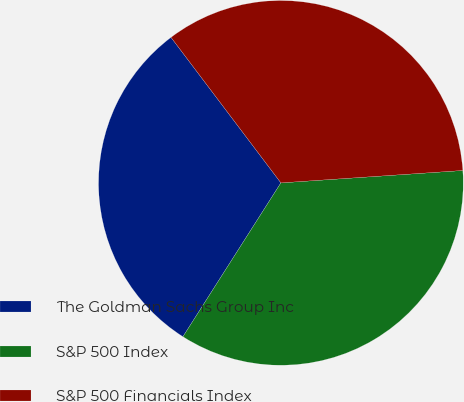Convert chart. <chart><loc_0><loc_0><loc_500><loc_500><pie_chart><fcel>The Goldman Sachs Group Inc<fcel>S&P 500 Index<fcel>S&P 500 Financials Index<nl><fcel>30.68%<fcel>35.11%<fcel>34.21%<nl></chart> 